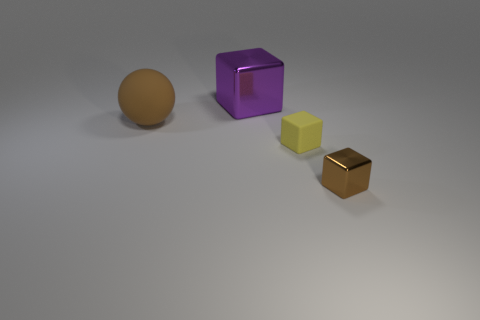There is a block that is the same size as the ball; what material is it?
Your answer should be compact. Metal. Is there a large purple object that has the same material as the small brown block?
Your response must be concise. Yes. What is the shape of the brown object in front of the small rubber thing that is on the right side of the metallic block that is behind the small metallic thing?
Your answer should be compact. Cube. Does the brown shiny object have the same size as the rubber object that is on the right side of the purple shiny thing?
Your answer should be compact. Yes. What is the shape of the thing that is on the left side of the yellow object and in front of the large block?
Provide a short and direct response. Sphere. What number of large things are either brown rubber balls or purple objects?
Your response must be concise. 2. Are there the same number of shiny cubes to the right of the large purple object and large metallic objects that are in front of the rubber ball?
Provide a succinct answer. No. What number of other things are the same color as the large metallic object?
Give a very brief answer. 0. Is the number of big brown balls left of the brown block the same as the number of large things?
Your answer should be compact. No. Is the yellow rubber object the same size as the brown metal cube?
Provide a succinct answer. Yes. 